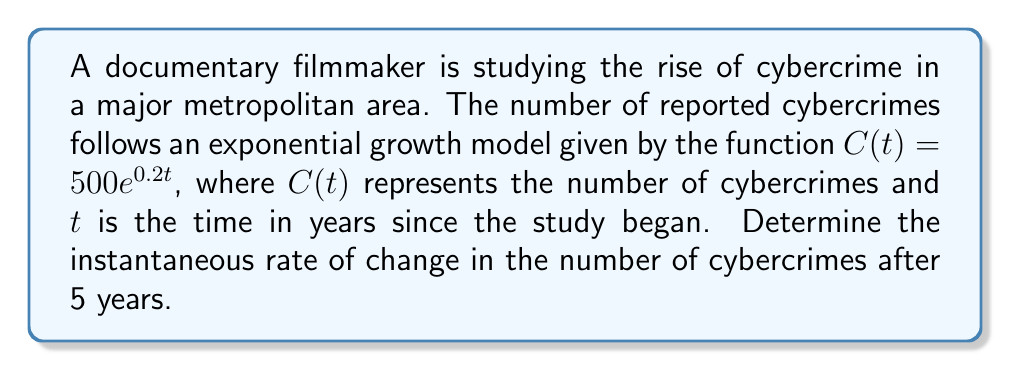Provide a solution to this math problem. To find the instantaneous rate of change, we need to calculate the derivative of the function $C(t)$ and evaluate it at $t=5$.

Step 1: Find the derivative of $C(t)$.
The derivative of $e^x$ is $e^x$, and we use the chain rule.
$$\frac{d}{dt}C(t) = 500 \cdot \frac{d}{dt}(e^{0.2t}) = 500 \cdot 0.2e^{0.2t} = 100e^{0.2t}$$

Step 2: Evaluate the derivative at $t=5$.
$$\frac{d}{dt}C(5) = 100e^{0.2(5)} = 100e^1 = 100e \approx 271.828$$

The instantaneous rate of change after 5 years is approximately 271.828 cybercrimes per year.
Answer: $100e \approx 271.828$ cybercrimes/year 